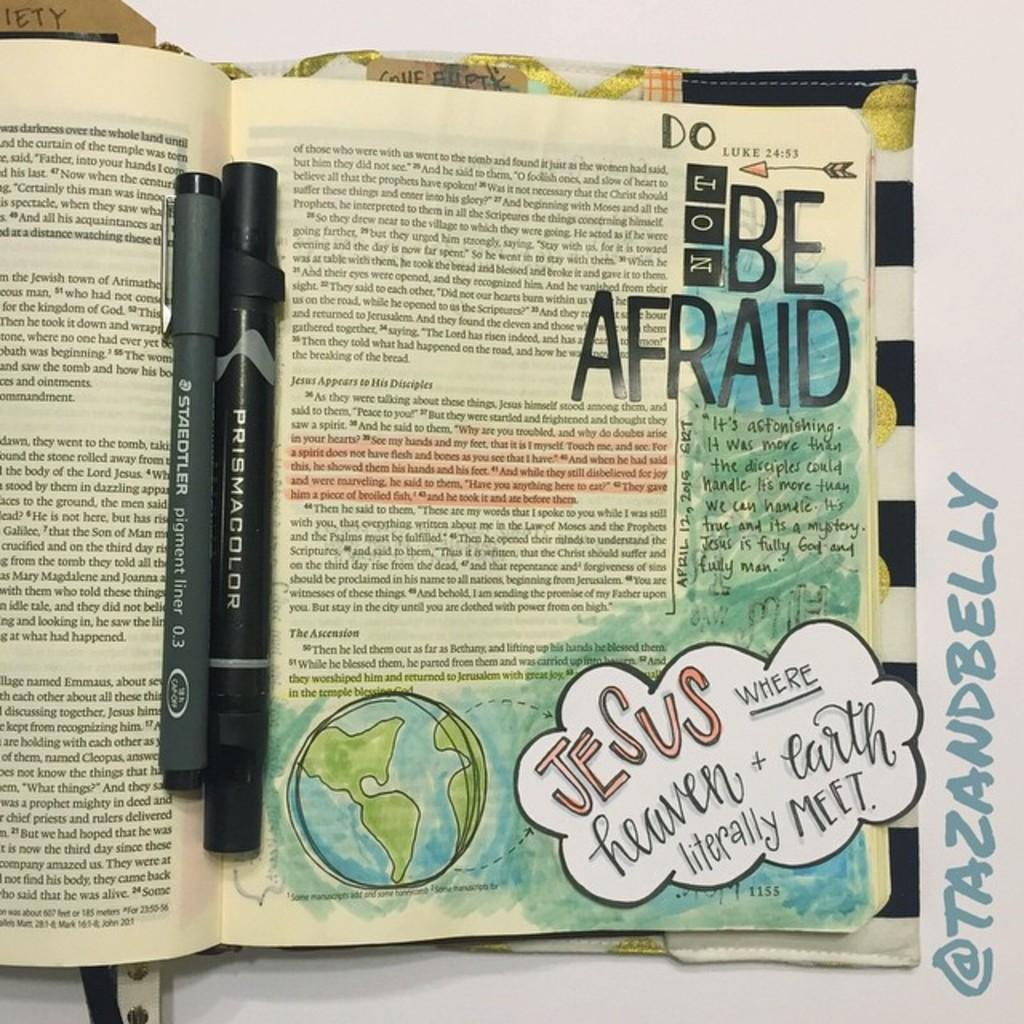<image>
Present a compact description of the photo's key features. A book with the words do not be afraid  near the top has colorful illustrations at the bottom. 